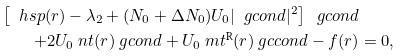<formula> <loc_0><loc_0><loc_500><loc_500>\left [ \ h s p ( r ) - \lambda _ { 2 } + ( N _ { 0 } + \Delta N _ { 0 } ) U _ { 0 } | \ g c o n d | ^ { 2 } \right ] \ g c o n d & \\ + 2 U _ { 0 } \ n t ( r ) \ g c o n d + U _ { 0 } \ m t ^ { \text {R} } ( r ) \ g c c o n d - f ( r ) & = 0 ,</formula> 